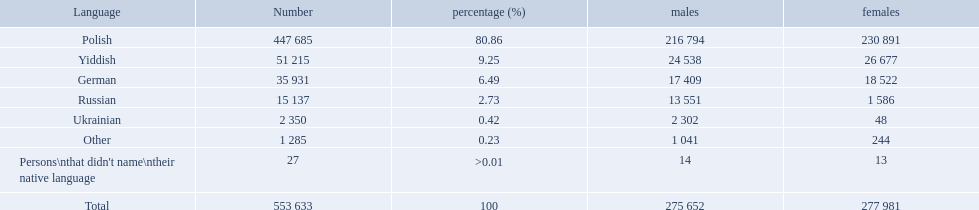What was the least spoken language Ukrainian. What was the most spoken? Polish. What are all of the languages? Polish, Yiddish, German, Russian, Ukrainian, Other, Persons\nthat didn't name\ntheir native language. And how many people speak these languages? 447 685, 51 215, 35 931, 15 137, 2 350, 1 285, 27. Which language is used by most people? Polish. Which language options are listed? Polish, Yiddish, German, Russian, Ukrainian, Other, Persons\nthat didn't name\ntheir native language. Of these, which did .42% of the people select? Ukrainian. How many speakers are depicted in polish? 447 685. How many depicted speakers are yiddish? 51 215. What is the overall count of speakers? 553 633. What language choices are mentioned? Polish, Yiddish, German, Russian, Ukrainian, Other, Persons\nthat didn't name\ntheir native language. Among them, which one was chosen by .42% of individuals? Ukrainian. What language selections are available? Polish, Yiddish, German, Russian, Ukrainian, Other, Persons\nthat didn't name\ntheir native language. Out of these, which was selected by .42% of the participants? Ukrainian. In the plock governorate, what was the largest percentage of people speaking one language? 80.86. What language was spoken by 80.86% of the individuals? Polish. What was the greatest percentage of a particular language spoken in the plock governorate? 80.86. Which language was spoken by the majority, at 80.86% of the people? Polish. What is the number of speakers for the polish language? 447 685. How many speakers are there for the yiddish language? 51 215. Could you parse the entire table? {'header': ['Language', 'Number', 'percentage (%)', 'males', 'females'], 'rows': [['Polish', '447 685', '80.86', '216 794', '230 891'], ['Yiddish', '51 215', '9.25', '24 538', '26 677'], ['German', '35 931', '6.49', '17 409', '18 522'], ['Russian', '15 137', '2.73', '13 551', '1 586'], ['Ukrainian', '2 350', '0.42', '2 302', '48'], ['Other', '1 285', '0.23', '1 041', '244'], ["Persons\\nthat didn't name\\ntheir native language", '27', '>0.01', '14', '13'], ['Total', '553 633', '100', '275 652', '277 981']]} What is the overall count of speakers? 553 633. What are the population percentages? 80.86, 9.25, 6.49, 2.73, 0.42, 0.23, >0.01. Which language has a 0.42% representation? Ukrainian. 